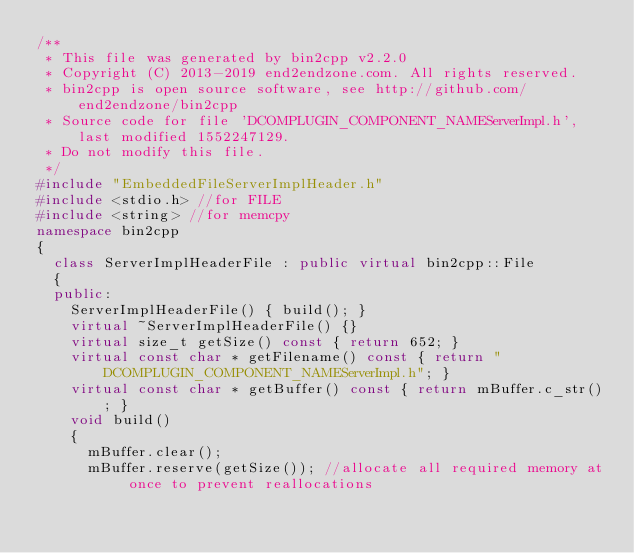<code> <loc_0><loc_0><loc_500><loc_500><_C++_>/**
 * This file was generated by bin2cpp v2.2.0
 * Copyright (C) 2013-2019 end2endzone.com. All rights reserved.
 * bin2cpp is open source software, see http://github.com/end2endzone/bin2cpp
 * Source code for file 'DCOMPLUGIN_COMPONENT_NAMEServerImpl.h', last modified 1552247129.
 * Do not modify this file.
 */
#include "EmbeddedFileServerImplHeader.h"
#include <stdio.h> //for FILE
#include <string> //for memcpy
namespace bin2cpp
{
  class ServerImplHeaderFile : public virtual bin2cpp::File
  {
  public:
    ServerImplHeaderFile() { build(); }
    virtual ~ServerImplHeaderFile() {}
    virtual size_t getSize() const { return 652; }
    virtual const char * getFilename() const { return "DCOMPLUGIN_COMPONENT_NAMEServerImpl.h"; }
    virtual const char * getBuffer() const { return mBuffer.c_str(); }
    void build()
    {
      mBuffer.clear();
      mBuffer.reserve(getSize()); //allocate all required memory at once to prevent reallocations</code> 